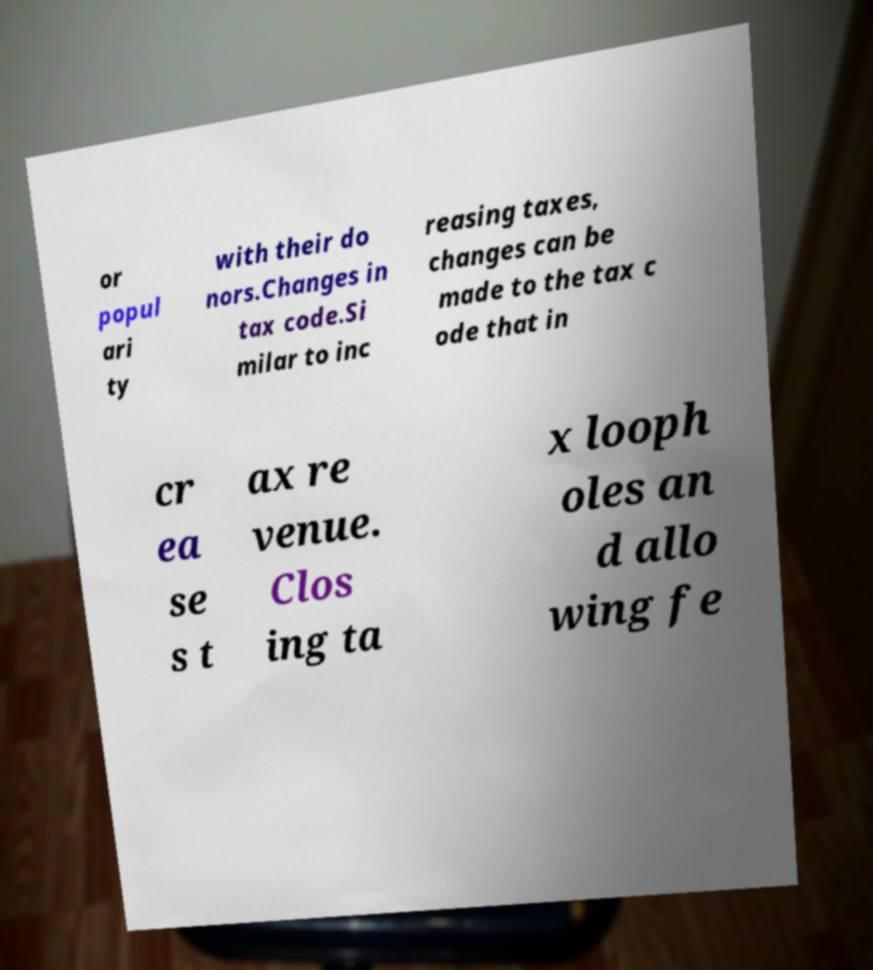There's text embedded in this image that I need extracted. Can you transcribe it verbatim? or popul ari ty with their do nors.Changes in tax code.Si milar to inc reasing taxes, changes can be made to the tax c ode that in cr ea se s t ax re venue. Clos ing ta x looph oles an d allo wing fe 